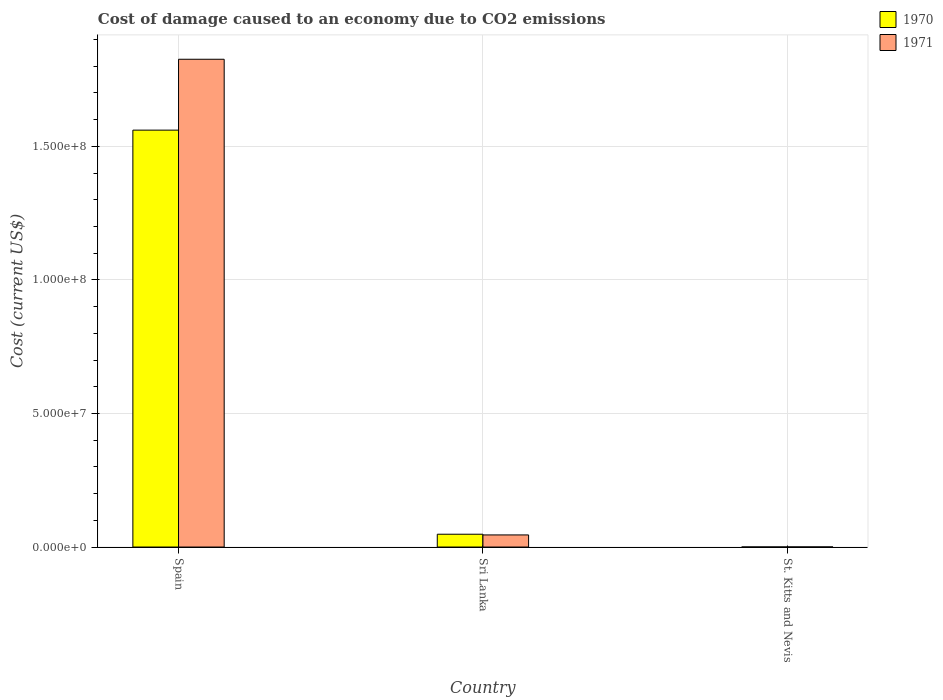Are the number of bars on each tick of the X-axis equal?
Offer a terse response. Yes. How many bars are there on the 3rd tick from the left?
Keep it short and to the point. 2. How many bars are there on the 1st tick from the right?
Offer a terse response. 2. What is the label of the 2nd group of bars from the left?
Keep it short and to the point. Sri Lanka. In how many cases, is the number of bars for a given country not equal to the number of legend labels?
Your answer should be very brief. 0. What is the cost of damage caused due to CO2 emissisons in 1971 in Spain?
Give a very brief answer. 1.83e+08. Across all countries, what is the maximum cost of damage caused due to CO2 emissisons in 1970?
Make the answer very short. 1.56e+08. Across all countries, what is the minimum cost of damage caused due to CO2 emissisons in 1971?
Make the answer very short. 4.16e+04. In which country was the cost of damage caused due to CO2 emissisons in 1970 minimum?
Provide a succinct answer. St. Kitts and Nevis. What is the total cost of damage caused due to CO2 emissisons in 1970 in the graph?
Your response must be concise. 1.61e+08. What is the difference between the cost of damage caused due to CO2 emissisons in 1971 in Sri Lanka and that in St. Kitts and Nevis?
Give a very brief answer. 4.50e+06. What is the difference between the cost of damage caused due to CO2 emissisons in 1970 in Sri Lanka and the cost of damage caused due to CO2 emissisons in 1971 in St. Kitts and Nevis?
Your answer should be very brief. 4.76e+06. What is the average cost of damage caused due to CO2 emissisons in 1970 per country?
Offer a terse response. 5.36e+07. What is the difference between the cost of damage caused due to CO2 emissisons of/in 1970 and cost of damage caused due to CO2 emissisons of/in 1971 in Spain?
Offer a terse response. -2.65e+07. In how many countries, is the cost of damage caused due to CO2 emissisons in 1970 greater than 160000000 US$?
Your response must be concise. 0. What is the ratio of the cost of damage caused due to CO2 emissisons in 1970 in Spain to that in St. Kitts and Nevis?
Provide a short and direct response. 4555.29. Is the cost of damage caused due to CO2 emissisons in 1970 in Spain less than that in Sri Lanka?
Ensure brevity in your answer.  No. Is the difference between the cost of damage caused due to CO2 emissisons in 1970 in Spain and Sri Lanka greater than the difference between the cost of damage caused due to CO2 emissisons in 1971 in Spain and Sri Lanka?
Offer a very short reply. No. What is the difference between the highest and the second highest cost of damage caused due to CO2 emissisons in 1971?
Give a very brief answer. 4.50e+06. What is the difference between the highest and the lowest cost of damage caused due to CO2 emissisons in 1970?
Keep it short and to the point. 1.56e+08. In how many countries, is the cost of damage caused due to CO2 emissisons in 1971 greater than the average cost of damage caused due to CO2 emissisons in 1971 taken over all countries?
Ensure brevity in your answer.  1. Is the sum of the cost of damage caused due to CO2 emissisons in 1970 in Spain and St. Kitts and Nevis greater than the maximum cost of damage caused due to CO2 emissisons in 1971 across all countries?
Make the answer very short. No. How many countries are there in the graph?
Provide a short and direct response. 3. What is the difference between two consecutive major ticks on the Y-axis?
Your answer should be compact. 5.00e+07. Are the values on the major ticks of Y-axis written in scientific E-notation?
Your answer should be compact. Yes. Does the graph contain any zero values?
Provide a short and direct response. No. Does the graph contain grids?
Offer a very short reply. Yes. How many legend labels are there?
Your answer should be very brief. 2. What is the title of the graph?
Keep it short and to the point. Cost of damage caused to an economy due to CO2 emissions. Does "1971" appear as one of the legend labels in the graph?
Your answer should be very brief. Yes. What is the label or title of the Y-axis?
Keep it short and to the point. Cost (current US$). What is the Cost (current US$) of 1970 in Spain?
Your response must be concise. 1.56e+08. What is the Cost (current US$) of 1971 in Spain?
Your answer should be very brief. 1.83e+08. What is the Cost (current US$) of 1970 in Sri Lanka?
Keep it short and to the point. 4.80e+06. What is the Cost (current US$) of 1971 in Sri Lanka?
Ensure brevity in your answer.  4.54e+06. What is the Cost (current US$) of 1970 in St. Kitts and Nevis?
Provide a short and direct response. 3.43e+04. What is the Cost (current US$) of 1971 in St. Kitts and Nevis?
Your answer should be compact. 4.16e+04. Across all countries, what is the maximum Cost (current US$) of 1970?
Give a very brief answer. 1.56e+08. Across all countries, what is the maximum Cost (current US$) in 1971?
Make the answer very short. 1.83e+08. Across all countries, what is the minimum Cost (current US$) of 1970?
Offer a very short reply. 3.43e+04. Across all countries, what is the minimum Cost (current US$) in 1971?
Provide a short and direct response. 4.16e+04. What is the total Cost (current US$) in 1970 in the graph?
Give a very brief answer. 1.61e+08. What is the total Cost (current US$) in 1971 in the graph?
Provide a succinct answer. 1.87e+08. What is the difference between the Cost (current US$) of 1970 in Spain and that in Sri Lanka?
Your answer should be compact. 1.51e+08. What is the difference between the Cost (current US$) in 1971 in Spain and that in Sri Lanka?
Keep it short and to the point. 1.78e+08. What is the difference between the Cost (current US$) in 1970 in Spain and that in St. Kitts and Nevis?
Keep it short and to the point. 1.56e+08. What is the difference between the Cost (current US$) in 1971 in Spain and that in St. Kitts and Nevis?
Provide a short and direct response. 1.83e+08. What is the difference between the Cost (current US$) in 1970 in Sri Lanka and that in St. Kitts and Nevis?
Offer a very short reply. 4.77e+06. What is the difference between the Cost (current US$) of 1971 in Sri Lanka and that in St. Kitts and Nevis?
Provide a short and direct response. 4.50e+06. What is the difference between the Cost (current US$) of 1970 in Spain and the Cost (current US$) of 1971 in Sri Lanka?
Offer a very short reply. 1.52e+08. What is the difference between the Cost (current US$) of 1970 in Spain and the Cost (current US$) of 1971 in St. Kitts and Nevis?
Offer a terse response. 1.56e+08. What is the difference between the Cost (current US$) in 1970 in Sri Lanka and the Cost (current US$) in 1971 in St. Kitts and Nevis?
Your answer should be compact. 4.76e+06. What is the average Cost (current US$) in 1970 per country?
Provide a succinct answer. 5.36e+07. What is the average Cost (current US$) of 1971 per country?
Your response must be concise. 6.24e+07. What is the difference between the Cost (current US$) in 1970 and Cost (current US$) in 1971 in Spain?
Your answer should be very brief. -2.65e+07. What is the difference between the Cost (current US$) in 1970 and Cost (current US$) in 1971 in Sri Lanka?
Offer a very short reply. 2.64e+05. What is the difference between the Cost (current US$) in 1970 and Cost (current US$) in 1971 in St. Kitts and Nevis?
Your response must be concise. -7366.56. What is the ratio of the Cost (current US$) in 1970 in Spain to that in Sri Lanka?
Offer a terse response. 32.5. What is the ratio of the Cost (current US$) of 1971 in Spain to that in Sri Lanka?
Your answer should be compact. 40.24. What is the ratio of the Cost (current US$) of 1970 in Spain to that in St. Kitts and Nevis?
Provide a short and direct response. 4555.29. What is the ratio of the Cost (current US$) in 1971 in Spain to that in St. Kitts and Nevis?
Keep it short and to the point. 4386.5. What is the ratio of the Cost (current US$) of 1970 in Sri Lanka to that in St. Kitts and Nevis?
Your response must be concise. 140.14. What is the ratio of the Cost (current US$) of 1971 in Sri Lanka to that in St. Kitts and Nevis?
Provide a succinct answer. 109. What is the difference between the highest and the second highest Cost (current US$) in 1970?
Make the answer very short. 1.51e+08. What is the difference between the highest and the second highest Cost (current US$) in 1971?
Keep it short and to the point. 1.78e+08. What is the difference between the highest and the lowest Cost (current US$) of 1970?
Make the answer very short. 1.56e+08. What is the difference between the highest and the lowest Cost (current US$) in 1971?
Provide a short and direct response. 1.83e+08. 